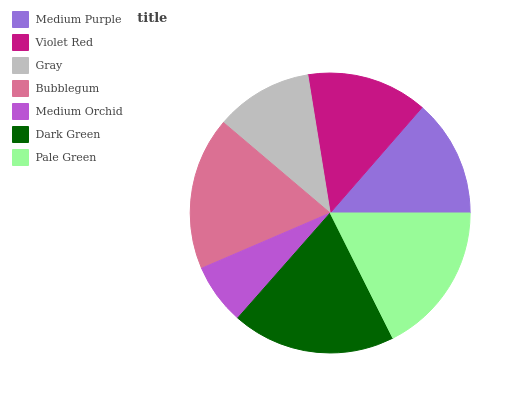Is Medium Orchid the minimum?
Answer yes or no. Yes. Is Dark Green the maximum?
Answer yes or no. Yes. Is Violet Red the minimum?
Answer yes or no. No. Is Violet Red the maximum?
Answer yes or no. No. Is Violet Red greater than Medium Purple?
Answer yes or no. Yes. Is Medium Purple less than Violet Red?
Answer yes or no. Yes. Is Medium Purple greater than Violet Red?
Answer yes or no. No. Is Violet Red less than Medium Purple?
Answer yes or no. No. Is Violet Red the high median?
Answer yes or no. Yes. Is Violet Red the low median?
Answer yes or no. Yes. Is Gray the high median?
Answer yes or no. No. Is Medium Purple the low median?
Answer yes or no. No. 